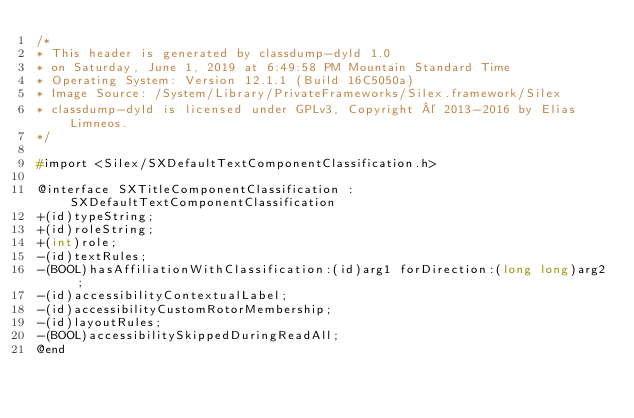Convert code to text. <code><loc_0><loc_0><loc_500><loc_500><_C_>/*
* This header is generated by classdump-dyld 1.0
* on Saturday, June 1, 2019 at 6:49:58 PM Mountain Standard Time
* Operating System: Version 12.1.1 (Build 16C5050a)
* Image Source: /System/Library/PrivateFrameworks/Silex.framework/Silex
* classdump-dyld is licensed under GPLv3, Copyright © 2013-2016 by Elias Limneos.
*/

#import <Silex/SXDefaultTextComponentClassification.h>

@interface SXTitleComponentClassification : SXDefaultTextComponentClassification
+(id)typeString;
+(id)roleString;
+(int)role;
-(id)textRules;
-(BOOL)hasAffiliationWithClassification:(id)arg1 forDirection:(long long)arg2 ;
-(id)accessibilityContextualLabel;
-(id)accessibilityCustomRotorMembership;
-(id)layoutRules;
-(BOOL)accessibilitySkippedDuringReadAll;
@end

</code> 